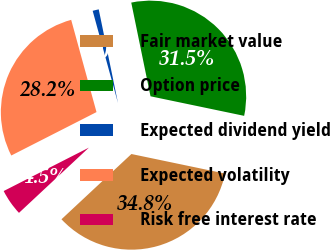Convert chart to OTSL. <chart><loc_0><loc_0><loc_500><loc_500><pie_chart><fcel>Fair market value<fcel>Option price<fcel>Expected dividend yield<fcel>Expected volatility<fcel>Risk free interest rate<nl><fcel>34.77%<fcel>31.5%<fcel>1.04%<fcel>28.23%<fcel>4.45%<nl></chart> 